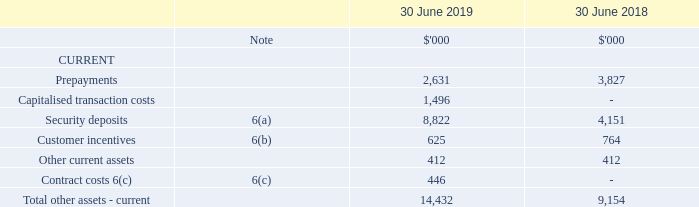6 Other assets (continued)
(a) Security deposits
Included in the security deposits was $8.8 million (2018: $4.2 million) relating to deposits held as security for bank guarantees.
(b) Customer incentives
Where customers are offered incentives in the form of free or discounted periods, the dollar value of the incentive is capitalised and amortised on a straight-line basis over the expected life of the contract.
(c) Contract Costs
From 1 July 2018, eligible costs that are expected to be recovered will be capitalised as a contract cost and amortised over the expected customer life.
How much was the security deposits in 2019?
Answer scale should be: thousand. 8,822. How was customer incentives amortised? On a straight-line basis over the expected life of the contract. How was contract costs amortised? Over the expected customer life. What was the percentage change in prepayments between 2018 and 2019?
Answer scale should be: percent. (2,631 - 3,827) / 3,827 
Answer: -31.25. What was the percentage change in security deposits between 2018 and 2019?
Answer scale should be: percent. (8,822 - 4,151) / 4,151 
Answer: 112.53. Which other assets (current) was the largest in 2018? 4,151 vs 3,827 vs 764 vs 412 
Answer: security deposits. 